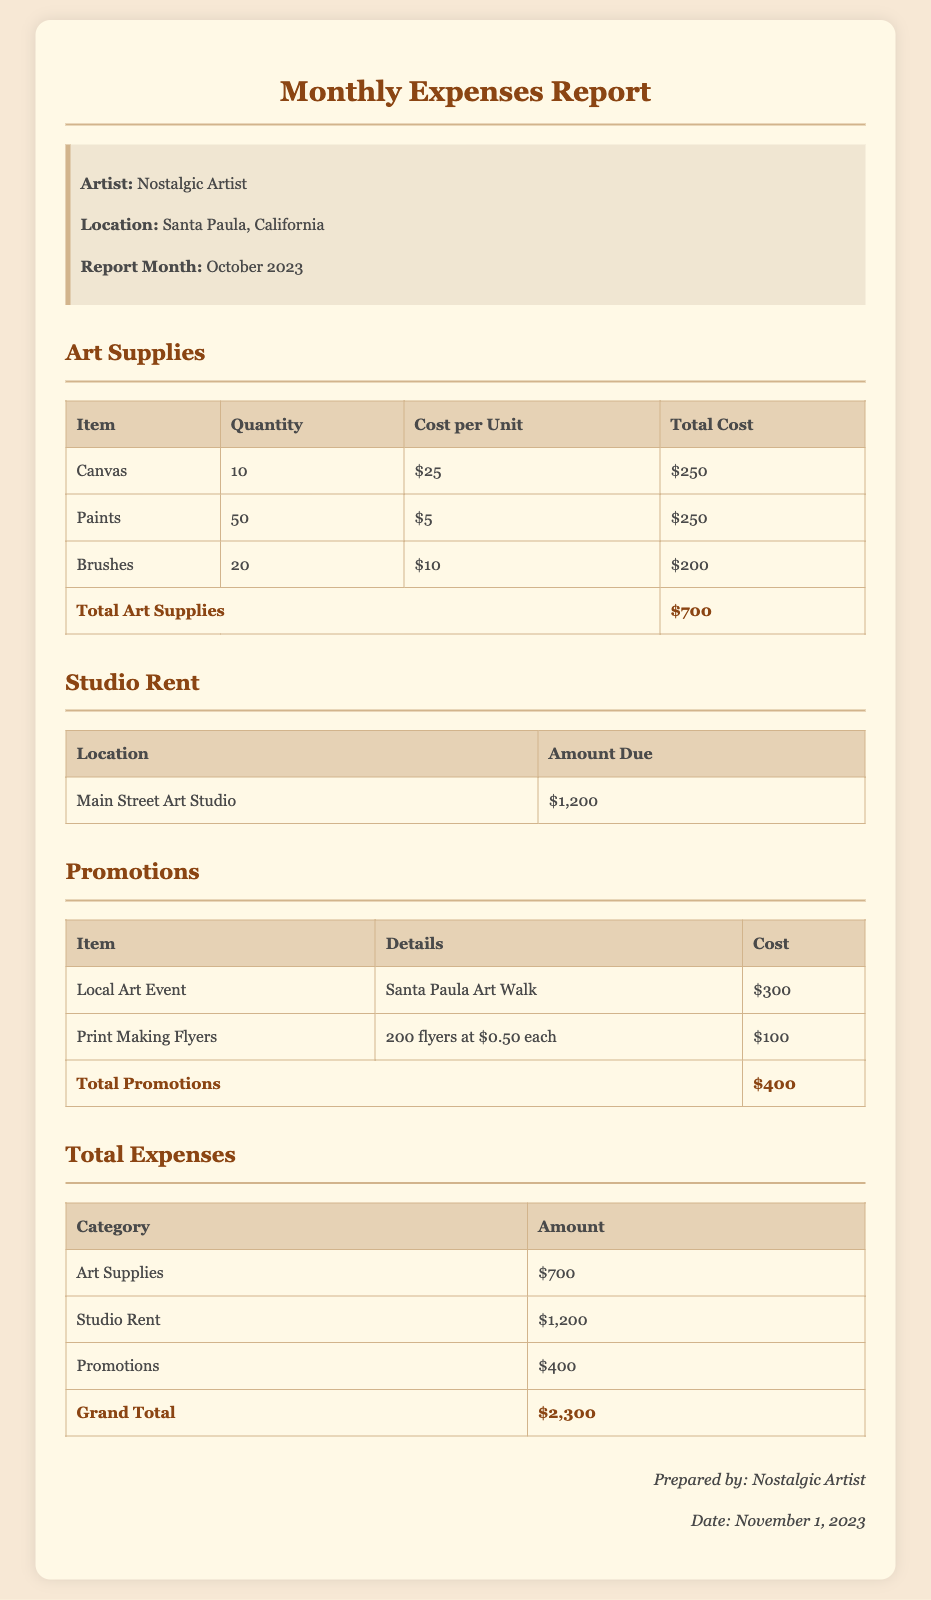what is the total cost of art supplies? The total cost of art supplies is listed at the bottom of the art supplies table in the document.
Answer: $700 how much is the studio rent? The studio rent amount is provided in the Studio Rent section.
Answer: $1,200 what is the cost of printing flyers? The cost of printing flyers can be found in the Promotions section of the report.
Answer: $100 who prepared the report? The name of the person who prepared the report is provided at the end of the document.
Answer: Nostalgic Artist what is the total expenses for the month? The total expenses are summarized in the Total Expenses section of the document.
Answer: $2,300 how many canvases were purchased? The quantity of canvases purchased is displayed in the art supplies table.
Answer: 10 what is the name of the local art event mentioned? The name of the local art event is found in the Promotions section of the report.
Answer: Santa Paula Art Walk what is the quantity of paints bought? The quantity of paints bought is provided in the art supplies table.
Answer: 50 